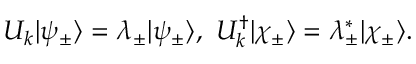Convert formula to latex. <formula><loc_0><loc_0><loc_500><loc_500>\begin{array} { r } { U _ { k } | \psi _ { \pm } \rangle = \lambda _ { \pm } | \psi _ { \pm } \rangle , U _ { k } ^ { \dagger } | \chi _ { \pm } \rangle = \lambda _ { \pm } ^ { \ast } | \chi _ { \pm } \rangle . } \end{array}</formula> 